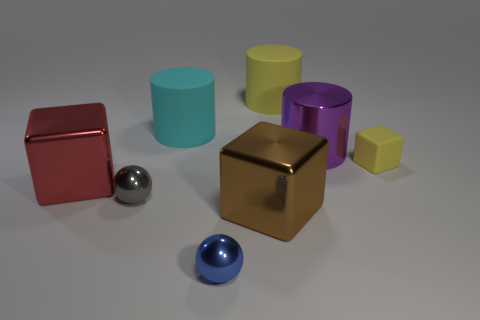What size is the object that is behind the purple metal cylinder and on the left side of the tiny blue metal sphere?
Offer a very short reply. Large. There is a blue sphere that is in front of the cyan object; what is its material?
Your answer should be very brief. Metal. Is the color of the rubber block the same as the big rubber thing that is to the right of the big brown metallic object?
Give a very brief answer. Yes. How many objects are either big things that are on the left side of the small blue metallic ball or large things in front of the large purple cylinder?
Offer a terse response. 3. There is a big thing that is both behind the tiny yellow object and in front of the cyan thing; what is its color?
Offer a terse response. Purple. Is the number of green metallic blocks greater than the number of large metal cubes?
Your response must be concise. No. There is a yellow object that is on the left side of the yellow cube; is its shape the same as the cyan thing?
Your answer should be compact. Yes. What number of metallic objects are either yellow cylinders or purple balls?
Provide a succinct answer. 0. Are there any tiny brown cylinders that have the same material as the small yellow thing?
Keep it short and to the point. No. What is the big yellow thing made of?
Give a very brief answer. Rubber. 